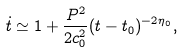<formula> <loc_0><loc_0><loc_500><loc_500>\dot { t } \simeq 1 + \frac { P ^ { 2 } } { 2 c _ { 0 } ^ { 2 } } ( t - t _ { 0 } ) ^ { - 2 \eta _ { 0 } } ,</formula> 